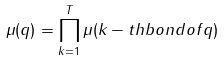Convert formula to latex. <formula><loc_0><loc_0><loc_500><loc_500>\mu ( q ) = \prod _ { k = 1 } ^ { T } \mu ( k - t h b o n d o f q )</formula> 